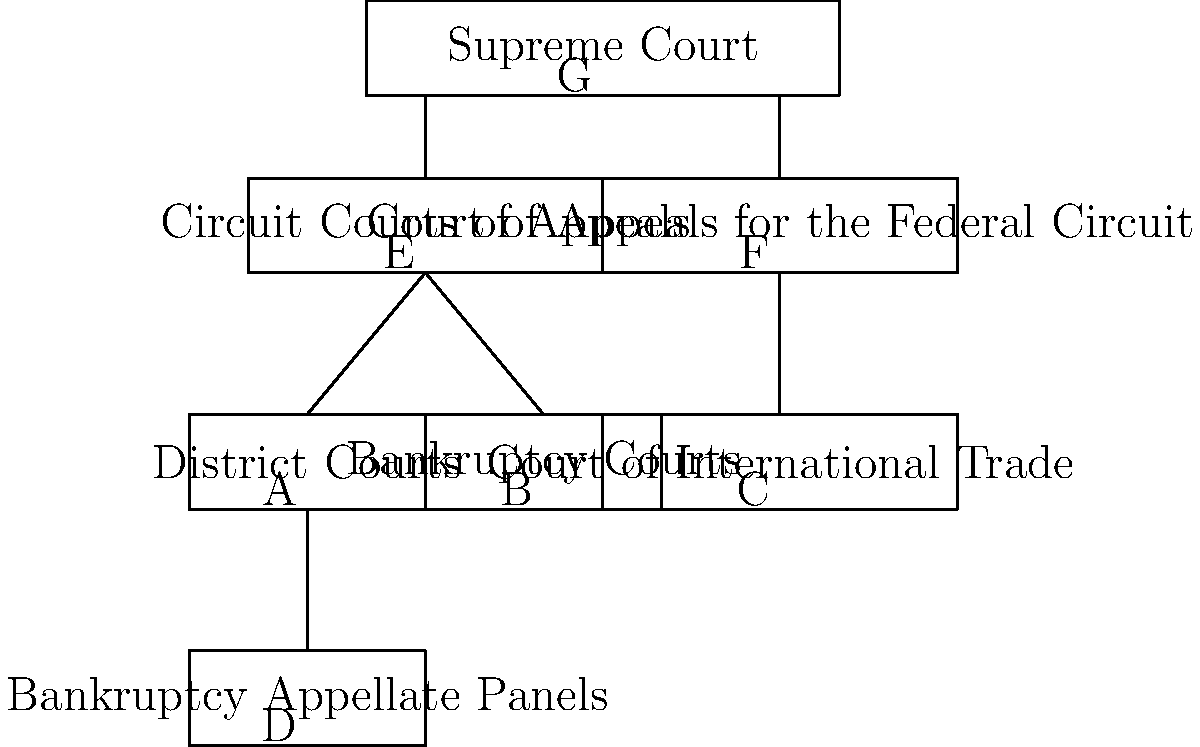Based on the diagram of the federal court system, which court(s) can directly appeal to the Supreme Court? To answer this question, we need to analyze the hierarchy presented in the diagram:

1. The Supreme Court is at the top of the hierarchy (labeled G).
2. Directly below the Supreme Court, we see two types of courts:
   a. Circuit Courts of Appeals (labeled E)
   b. Court of Appeals for the Federal Circuit (labeled F)
3. These two types of courts (E and F) are the only ones with direct lines connecting them to the Supreme Court.
4. The lower courts (A, B, C, and D) do not have direct lines to the Supreme Court. They must go through the appellate courts first.

Therefore, based on the diagram, only the Circuit Courts of Appeals and the Court of Appeals for the Federal Circuit can directly appeal to the Supreme Court.
Answer: Circuit Courts of Appeals and Court of Appeals for the Federal Circuit 